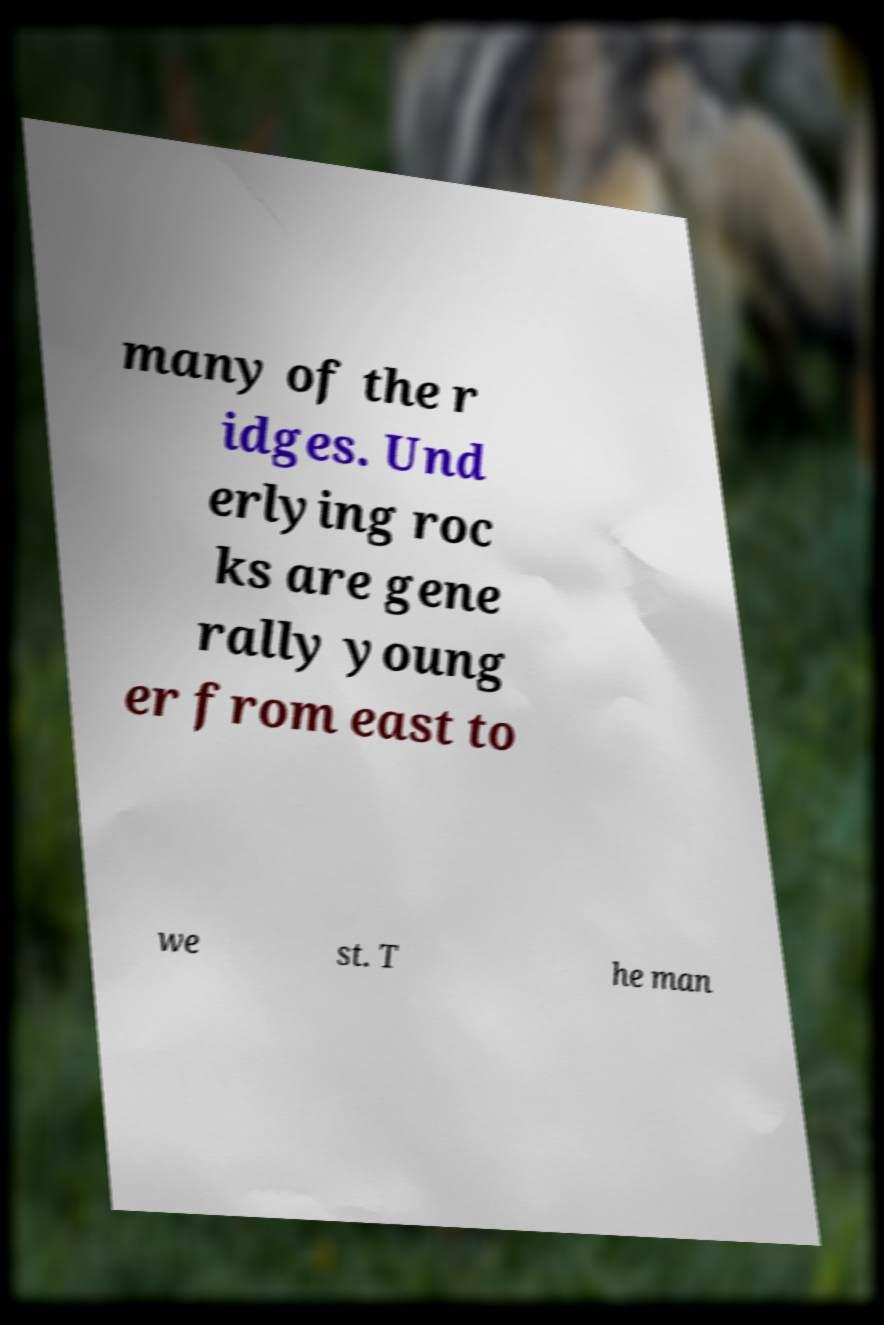Could you extract and type out the text from this image? many of the r idges. Und erlying roc ks are gene rally young er from east to we st. T he man 